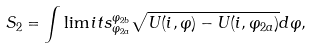<formula> <loc_0><loc_0><loc_500><loc_500>S _ { 2 } = \int \lim i t s _ { \varphi _ { 2 a } } ^ { \varphi _ { 2 b } } \sqrt { U ( i , \varphi ) - U ( i , \varphi _ { 2 a } ) } d \varphi ,</formula> 